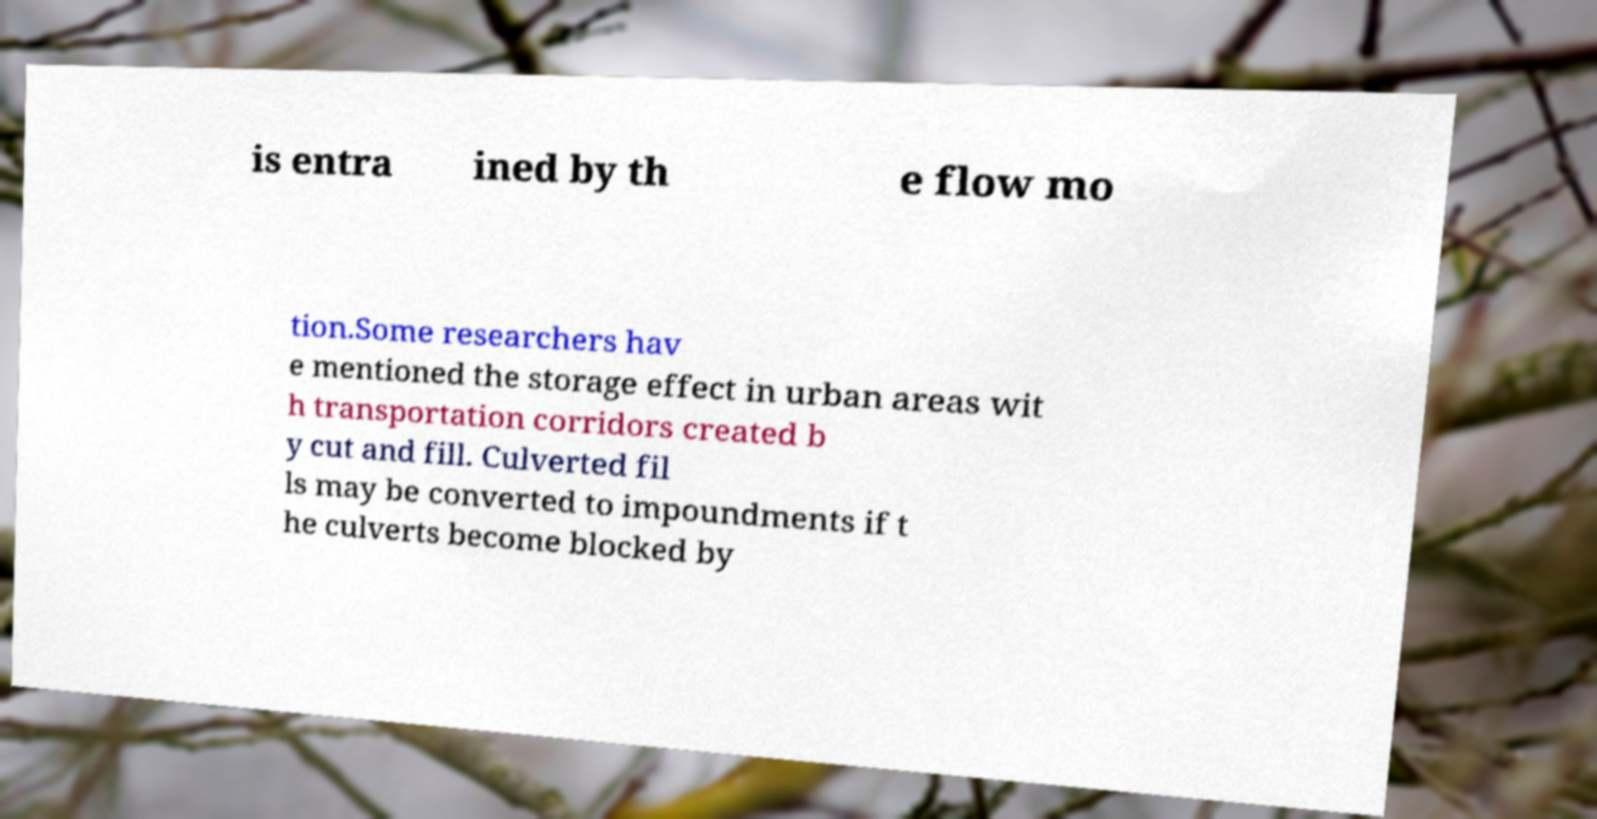Can you read and provide the text displayed in the image?This photo seems to have some interesting text. Can you extract and type it out for me? is entra ined by th e flow mo tion.Some researchers hav e mentioned the storage effect in urban areas wit h transportation corridors created b y cut and fill. Culverted fil ls may be converted to impoundments if t he culverts become blocked by 